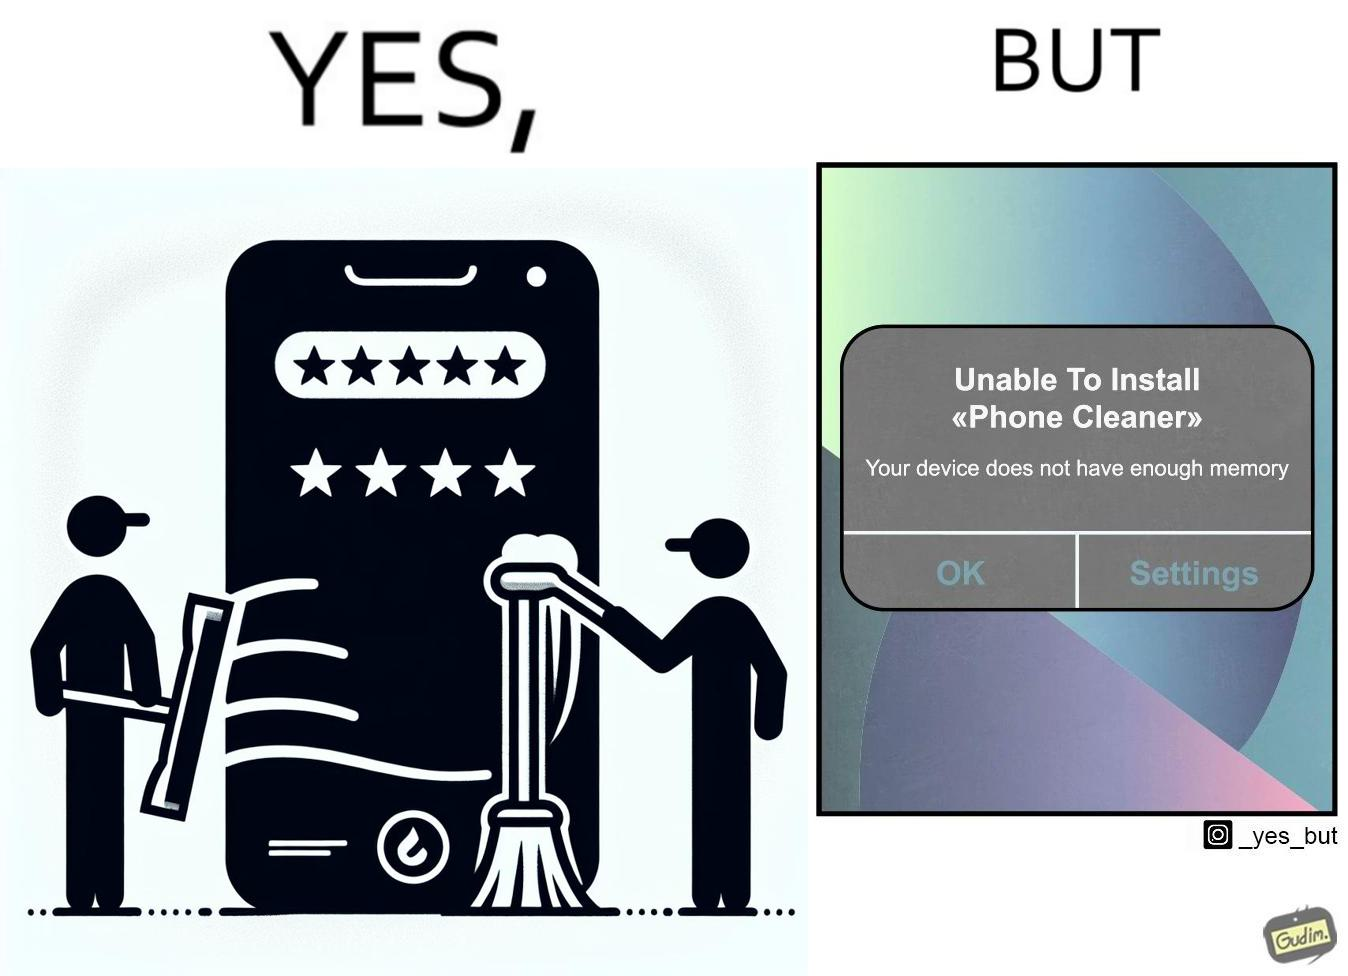What do you see in each half of this image? In the left part of the image: Phone cleaner app for cleaning phone memory, with a 4+ star rating. In the right part of the image: A pop-up message on a mobile device, showing that it is unable to install an app named "Phone cleaner" that due to insufficient availability of memory on the device. 